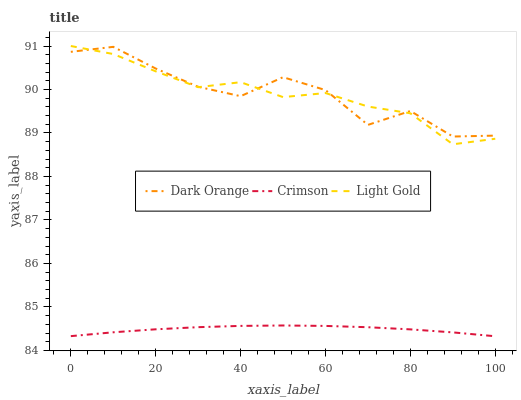Does Crimson have the minimum area under the curve?
Answer yes or no. Yes. Does Dark Orange have the maximum area under the curve?
Answer yes or no. Yes. Does Light Gold have the minimum area under the curve?
Answer yes or no. No. Does Light Gold have the maximum area under the curve?
Answer yes or no. No. Is Crimson the smoothest?
Answer yes or no. Yes. Is Dark Orange the roughest?
Answer yes or no. Yes. Is Light Gold the smoothest?
Answer yes or no. No. Is Light Gold the roughest?
Answer yes or no. No. Does Crimson have the lowest value?
Answer yes or no. Yes. Does Light Gold have the lowest value?
Answer yes or no. No. Does Light Gold have the highest value?
Answer yes or no. Yes. Does Dark Orange have the highest value?
Answer yes or no. No. Is Crimson less than Dark Orange?
Answer yes or no. Yes. Is Light Gold greater than Crimson?
Answer yes or no. Yes. Does Light Gold intersect Dark Orange?
Answer yes or no. Yes. Is Light Gold less than Dark Orange?
Answer yes or no. No. Is Light Gold greater than Dark Orange?
Answer yes or no. No. Does Crimson intersect Dark Orange?
Answer yes or no. No. 